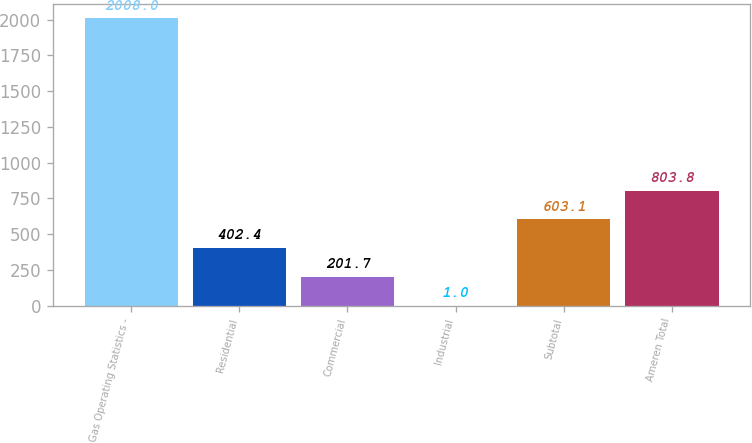Convert chart. <chart><loc_0><loc_0><loc_500><loc_500><bar_chart><fcel>Gas Operating Statistics -<fcel>Residential<fcel>Commercial<fcel>Industrial<fcel>Subtotal<fcel>Ameren Total<nl><fcel>2008<fcel>402.4<fcel>201.7<fcel>1<fcel>603.1<fcel>803.8<nl></chart> 